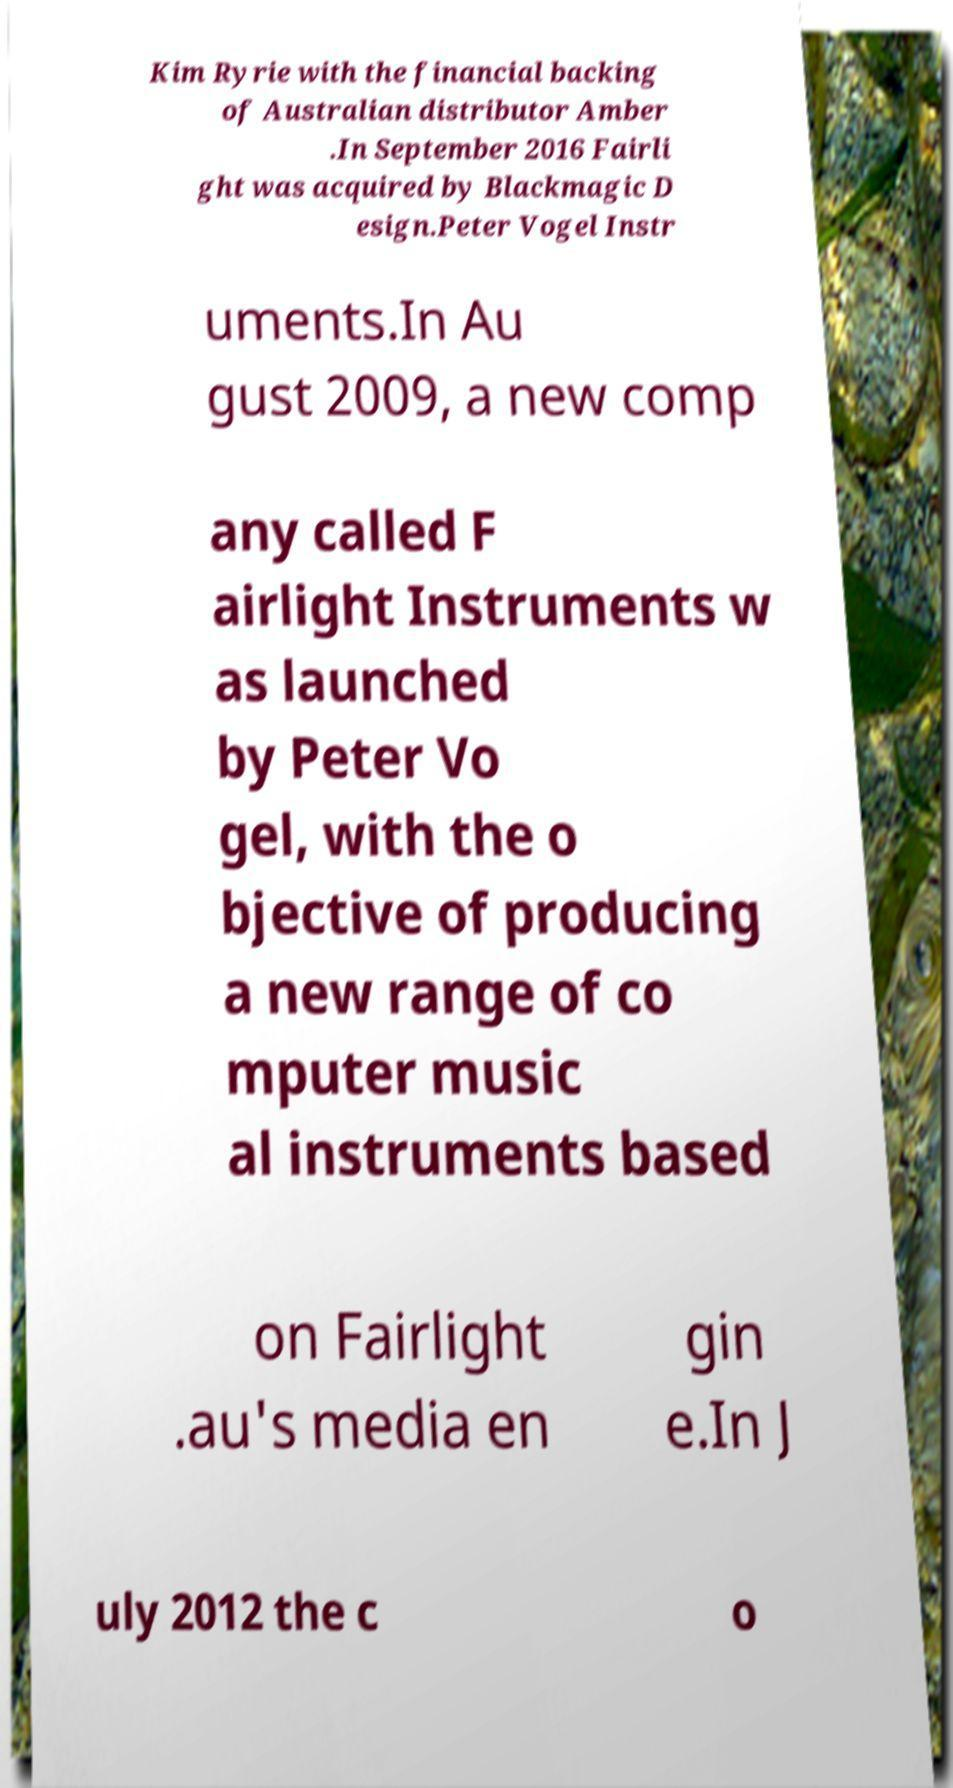Please identify and transcribe the text found in this image. Kim Ryrie with the financial backing of Australian distributor Amber .In September 2016 Fairli ght was acquired by Blackmagic D esign.Peter Vogel Instr uments.In Au gust 2009, a new comp any called F airlight Instruments w as launched by Peter Vo gel, with the o bjective of producing a new range of co mputer music al instruments based on Fairlight .au's media en gin e.In J uly 2012 the c o 